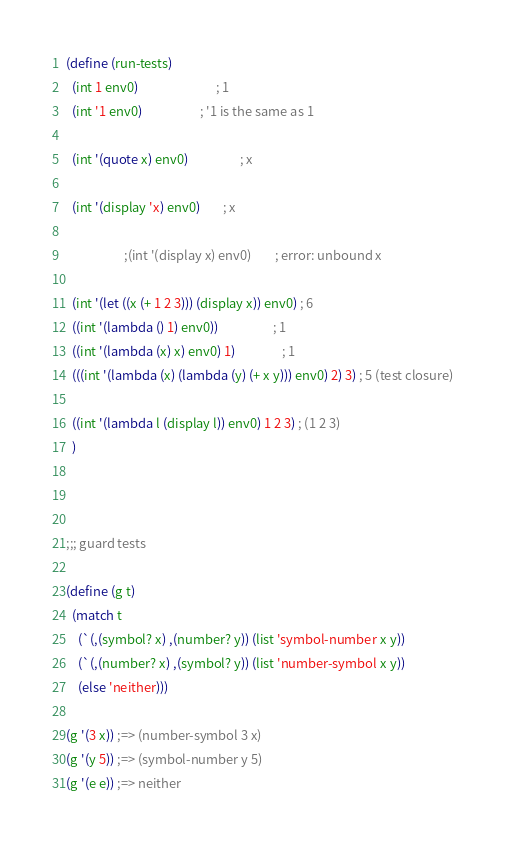<code> <loc_0><loc_0><loc_500><loc_500><_Scheme_>(define (run-tests)
  (int 1 env0)                           ; 1
  (int '1 env0)			        ; '1 is the same as 1

  (int '(quote x) env0)                  ; x

  (int '(display 'x) env0)		; x

					;(int '(display x) env0) 		; error: unbound x

  (int '(let ((x (+ 1 2 3))) (display x)) env0) ; 6
  ((int '(lambda () 1) env0))                   ; 1
  ((int '(lambda (x) x) env0) 1)                ; 1
  (((int '(lambda (x) (lambda (y) (+ x y))) env0) 2) 3) ; 5 (test closure)

  ((int '(lambda l (display l)) env0) 1 2 3) ; (1 2 3)
  )



;;; guard tests

(define (g t)
  (match t
    (`(,(symbol? x) ,(number? y)) (list 'symbol-number x y))
    (`(,(number? x) ,(symbol? y)) (list 'number-symbol x y))
    (else 'neither)))

(g '(3 x)) ;=> (number-symbol 3 x)
(g '(y 5)) ;=> (symbol-number y 5)
(g '(e e)) ;=> neither

</code> 